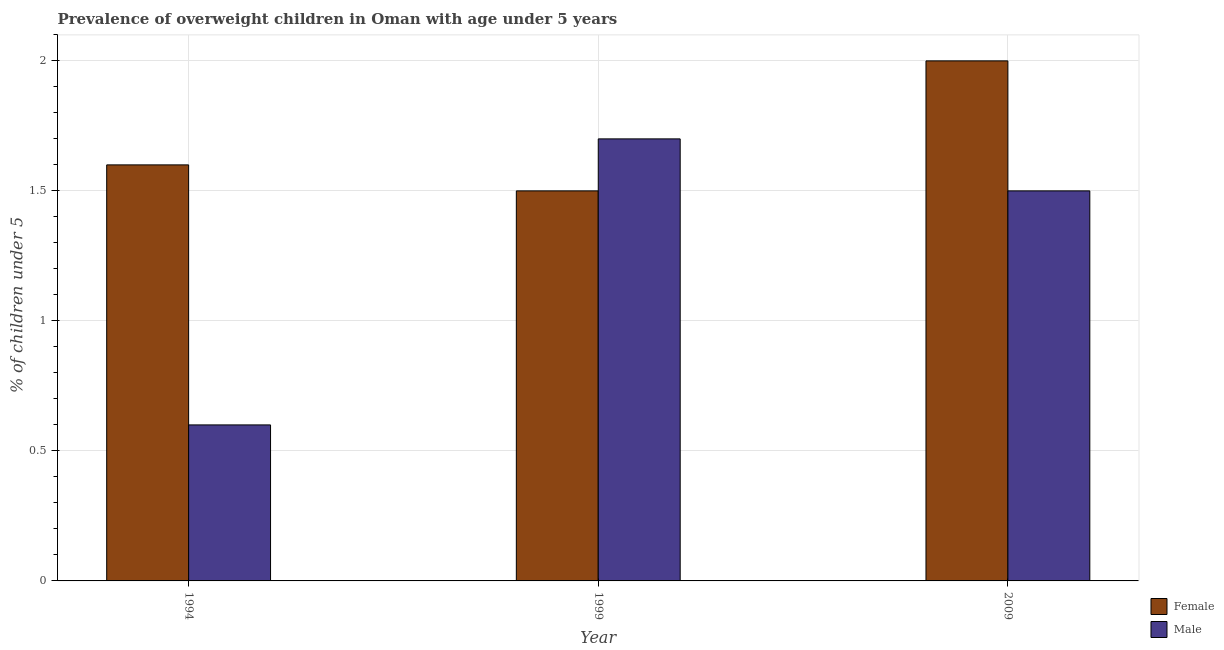How many different coloured bars are there?
Provide a succinct answer. 2. How many bars are there on the 1st tick from the left?
Give a very brief answer. 2. How many bars are there on the 3rd tick from the right?
Your response must be concise. 2. What is the label of the 2nd group of bars from the left?
Provide a succinct answer. 1999. What is the percentage of obese female children in 1999?
Your answer should be very brief. 1.5. Across all years, what is the maximum percentage of obese female children?
Your answer should be compact. 2. Across all years, what is the minimum percentage of obese male children?
Make the answer very short. 0.6. In which year was the percentage of obese male children maximum?
Provide a short and direct response. 1999. What is the total percentage of obese male children in the graph?
Ensure brevity in your answer.  3.8. What is the difference between the percentage of obese male children in 1999 and that in 2009?
Your answer should be compact. 0.2. What is the difference between the percentage of obese male children in 2009 and the percentage of obese female children in 1999?
Ensure brevity in your answer.  -0.2. What is the average percentage of obese female children per year?
Keep it short and to the point. 1.7. In how many years, is the percentage of obese male children greater than 2 %?
Offer a terse response. 0. What is the ratio of the percentage of obese female children in 1999 to that in 2009?
Offer a very short reply. 0.75. Is the percentage of obese female children in 1994 less than that in 2009?
Offer a terse response. Yes. Is the difference between the percentage of obese male children in 1994 and 1999 greater than the difference between the percentage of obese female children in 1994 and 1999?
Offer a very short reply. No. What is the difference between the highest and the second highest percentage of obese female children?
Your answer should be very brief. 0.4. What is the difference between the highest and the lowest percentage of obese male children?
Your response must be concise. 1.1. In how many years, is the percentage of obese female children greater than the average percentage of obese female children taken over all years?
Make the answer very short. 1. Is the sum of the percentage of obese female children in 1994 and 1999 greater than the maximum percentage of obese male children across all years?
Your answer should be compact. Yes. How many bars are there?
Your answer should be very brief. 6. Are the values on the major ticks of Y-axis written in scientific E-notation?
Provide a succinct answer. No. Where does the legend appear in the graph?
Provide a short and direct response. Bottom right. What is the title of the graph?
Give a very brief answer. Prevalence of overweight children in Oman with age under 5 years. Does "Non-resident workers" appear as one of the legend labels in the graph?
Your response must be concise. No. What is the label or title of the X-axis?
Make the answer very short. Year. What is the label or title of the Y-axis?
Keep it short and to the point.  % of children under 5. What is the  % of children under 5 of Female in 1994?
Your response must be concise. 1.6. What is the  % of children under 5 of Male in 1994?
Offer a very short reply. 0.6. What is the  % of children under 5 of Female in 1999?
Offer a very short reply. 1.5. What is the  % of children under 5 in Male in 1999?
Your answer should be very brief. 1.7. What is the  % of children under 5 of Male in 2009?
Provide a short and direct response. 1.5. Across all years, what is the maximum  % of children under 5 of Female?
Offer a very short reply. 2. Across all years, what is the maximum  % of children under 5 of Male?
Give a very brief answer. 1.7. Across all years, what is the minimum  % of children under 5 of Female?
Keep it short and to the point. 1.5. Across all years, what is the minimum  % of children under 5 of Male?
Your answer should be very brief. 0.6. What is the total  % of children under 5 in Male in the graph?
Make the answer very short. 3.8. What is the difference between the  % of children under 5 in Female in 1994 and that in 1999?
Ensure brevity in your answer.  0.1. What is the difference between the  % of children under 5 of Male in 1994 and that in 2009?
Make the answer very short. -0.9. What is the difference between the  % of children under 5 of Female in 1999 and that in 2009?
Keep it short and to the point. -0.5. What is the difference between the  % of children under 5 in Male in 1999 and that in 2009?
Offer a very short reply. 0.2. What is the difference between the  % of children under 5 in Female in 1994 and the  % of children under 5 in Male in 1999?
Your answer should be very brief. -0.1. What is the average  % of children under 5 in Female per year?
Offer a very short reply. 1.7. What is the average  % of children under 5 of Male per year?
Provide a succinct answer. 1.27. In the year 1994, what is the difference between the  % of children under 5 in Female and  % of children under 5 in Male?
Give a very brief answer. 1. What is the ratio of the  % of children under 5 in Female in 1994 to that in 1999?
Give a very brief answer. 1.07. What is the ratio of the  % of children under 5 of Male in 1994 to that in 1999?
Make the answer very short. 0.35. What is the ratio of the  % of children under 5 of Male in 1994 to that in 2009?
Your response must be concise. 0.4. What is the ratio of the  % of children under 5 in Male in 1999 to that in 2009?
Your answer should be very brief. 1.13. What is the difference between the highest and the second highest  % of children under 5 of Female?
Keep it short and to the point. 0.4. What is the difference between the highest and the lowest  % of children under 5 in Male?
Offer a terse response. 1.1. 